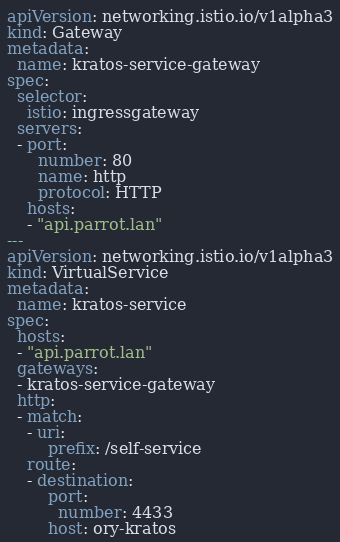<code> <loc_0><loc_0><loc_500><loc_500><_YAML_>apiVersion: networking.istio.io/v1alpha3
kind: Gateway
metadata:
  name: kratos-service-gateway
spec:
  selector:
    istio: ingressgateway
  servers:
  - port:
      number: 80
      name: http
      protocol: HTTP
    hosts:
    - "api.parrot.lan"
---
apiVersion: networking.istio.io/v1alpha3
kind: VirtualService
metadata:
  name: kratos-service
spec:
  hosts:
  - "api.parrot.lan"
  gateways:
  - kratos-service-gateway
  http:
  - match:
    - uri: 
        prefix: /self-service
    route:
    - destination:
        port:
          number: 4433
        host: ory-kratos
</code> 